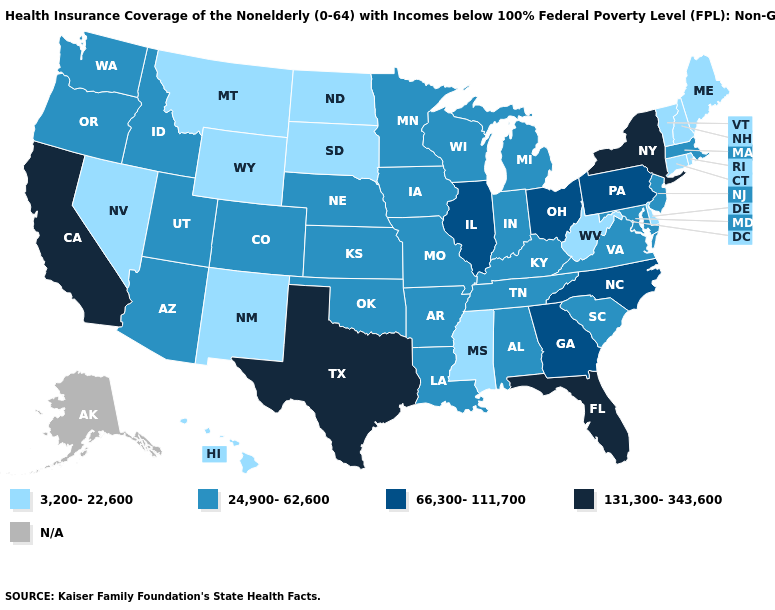Is the legend a continuous bar?
Quick response, please. No. Does the map have missing data?
Keep it brief. Yes. What is the value of New Jersey?
Concise answer only. 24,900-62,600. What is the value of Kansas?
Be succinct. 24,900-62,600. Name the states that have a value in the range 66,300-111,700?
Short answer required. Georgia, Illinois, North Carolina, Ohio, Pennsylvania. Does South Carolina have the highest value in the South?
Answer briefly. No. What is the value of North Carolina?
Answer briefly. 66,300-111,700. Name the states that have a value in the range 66,300-111,700?
Answer briefly. Georgia, Illinois, North Carolina, Ohio, Pennsylvania. Which states hav the highest value in the MidWest?
Answer briefly. Illinois, Ohio. Among the states that border Montana , does Idaho have the highest value?
Short answer required. Yes. Which states have the lowest value in the Northeast?
Answer briefly. Connecticut, Maine, New Hampshire, Rhode Island, Vermont. Which states have the highest value in the USA?
Short answer required. California, Florida, New York, Texas. 